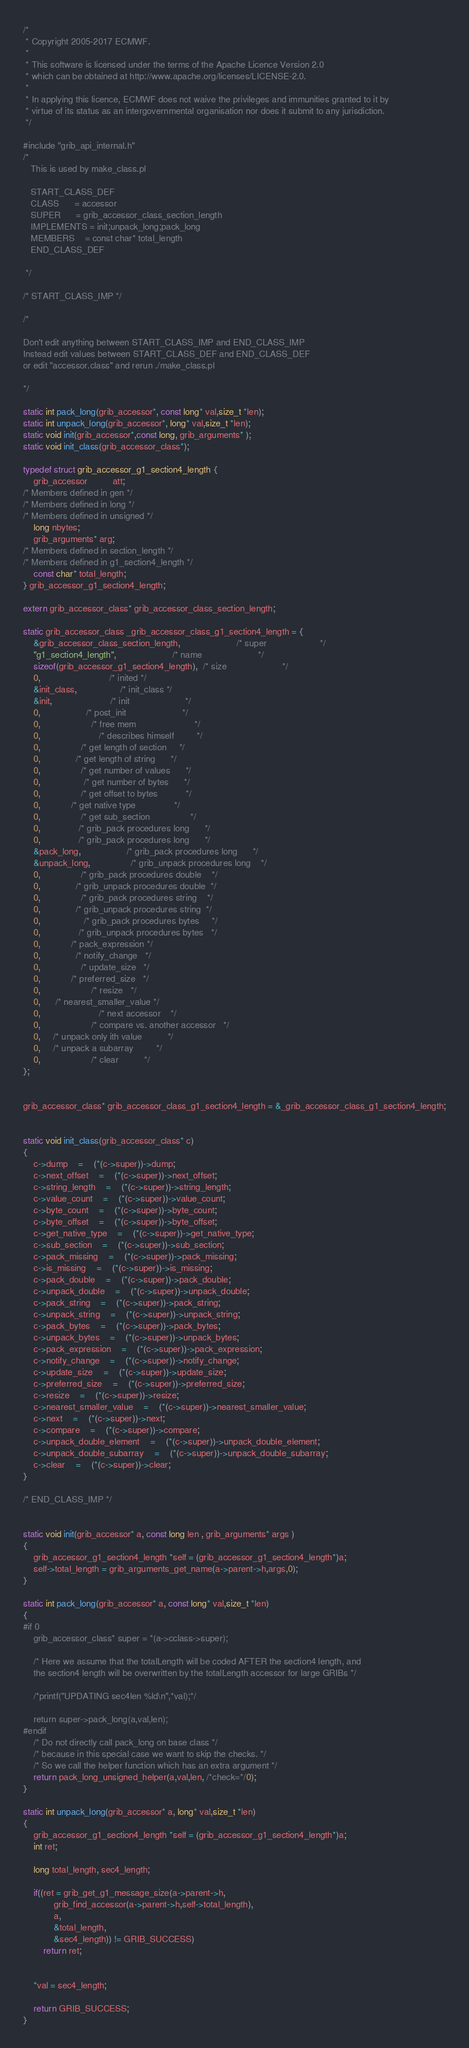Convert code to text. <code><loc_0><loc_0><loc_500><loc_500><_C_>/*
 * Copyright 2005-2017 ECMWF.
 *
 * This software is licensed under the terms of the Apache Licence Version 2.0
 * which can be obtained at http://www.apache.org/licenses/LICENSE-2.0.
 *
 * In applying this licence, ECMWF does not waive the privileges and immunities granted to it by
 * virtue of its status as an intergovernmental organisation nor does it submit to any jurisdiction.
 */

#include "grib_api_internal.h"
/* 
   This is used by make_class.pl

   START_CLASS_DEF
   CLASS      = accessor
   SUPER      = grib_accessor_class_section_length
   IMPLEMENTS = init;unpack_long;pack_long
   MEMBERS    = const char* total_length
   END_CLASS_DEF

 */

/* START_CLASS_IMP */

/*

Don't edit anything between START_CLASS_IMP and END_CLASS_IMP
Instead edit values between START_CLASS_DEF and END_CLASS_DEF
or edit "accessor.class" and rerun ./make_class.pl

*/

static int pack_long(grib_accessor*, const long* val,size_t *len);
static int unpack_long(grib_accessor*, long* val,size_t *len);
static void init(grib_accessor*,const long, grib_arguments* );
static void init_class(grib_accessor_class*);

typedef struct grib_accessor_g1_section4_length {
    grib_accessor          att;
/* Members defined in gen */
/* Members defined in long */
/* Members defined in unsigned */
	long nbytes;
	grib_arguments* arg;
/* Members defined in section_length */
/* Members defined in g1_section4_length */
	const char* total_length;
} grib_accessor_g1_section4_length;

extern grib_accessor_class* grib_accessor_class_section_length;

static grib_accessor_class _grib_accessor_class_g1_section4_length = {
    &grib_accessor_class_section_length,                      /* super                     */
    "g1_section4_length",                      /* name                      */
    sizeof(grib_accessor_g1_section4_length),  /* size                      */
    0,                           /* inited */
    &init_class,                 /* init_class */
    &init,                       /* init                      */
    0,                  /* post_init                      */
    0,                    /* free mem                       */
    0,                       /* describes himself         */
    0,                /* get length of section     */
    0,              /* get length of string      */
    0,                /* get number of values      */
    0,                 /* get number of bytes      */
    0,                /* get offset to bytes           */
    0,            /* get native type               */
    0,                /* get sub_section                */
    0,               /* grib_pack procedures long      */
    0,               /* grib_pack procedures long      */
    &pack_long,                  /* grib_pack procedures long      */
    &unpack_long,                /* grib_unpack procedures long    */
    0,                /* grib_pack procedures double    */
    0,              /* grib_unpack procedures double  */
    0,                /* grib_pack procedures string    */
    0,              /* grib_unpack procedures string  */
    0,                 /* grib_pack procedures bytes     */
    0,               /* grib_unpack procedures bytes   */
    0,            /* pack_expression */
    0,              /* notify_change   */
    0,                /* update_size   */
    0,            /* preferred_size   */
    0,                    /* resize   */
    0,      /* nearest_smaller_value */
    0,                       /* next accessor    */
    0,                    /* compare vs. another accessor   */
    0,     /* unpack only ith value          */
    0,     /* unpack a subarray         */
    0,             		/* clear          */
};


grib_accessor_class* grib_accessor_class_g1_section4_length = &_grib_accessor_class_g1_section4_length;


static void init_class(grib_accessor_class* c)
{
	c->dump	=	(*(c->super))->dump;
	c->next_offset	=	(*(c->super))->next_offset;
	c->string_length	=	(*(c->super))->string_length;
	c->value_count	=	(*(c->super))->value_count;
	c->byte_count	=	(*(c->super))->byte_count;
	c->byte_offset	=	(*(c->super))->byte_offset;
	c->get_native_type	=	(*(c->super))->get_native_type;
	c->sub_section	=	(*(c->super))->sub_section;
	c->pack_missing	=	(*(c->super))->pack_missing;
	c->is_missing	=	(*(c->super))->is_missing;
	c->pack_double	=	(*(c->super))->pack_double;
	c->unpack_double	=	(*(c->super))->unpack_double;
	c->pack_string	=	(*(c->super))->pack_string;
	c->unpack_string	=	(*(c->super))->unpack_string;
	c->pack_bytes	=	(*(c->super))->pack_bytes;
	c->unpack_bytes	=	(*(c->super))->unpack_bytes;
	c->pack_expression	=	(*(c->super))->pack_expression;
	c->notify_change	=	(*(c->super))->notify_change;
	c->update_size	=	(*(c->super))->update_size;
	c->preferred_size	=	(*(c->super))->preferred_size;
	c->resize	=	(*(c->super))->resize;
	c->nearest_smaller_value	=	(*(c->super))->nearest_smaller_value;
	c->next	=	(*(c->super))->next;
	c->compare	=	(*(c->super))->compare;
	c->unpack_double_element	=	(*(c->super))->unpack_double_element;
	c->unpack_double_subarray	=	(*(c->super))->unpack_double_subarray;
	c->clear	=	(*(c->super))->clear;
}

/* END_CLASS_IMP */


static void init(grib_accessor* a, const long len , grib_arguments* args )
{
    grib_accessor_g1_section4_length *self = (grib_accessor_g1_section4_length*)a;
	self->total_length = grib_arguments_get_name(a->parent->h,args,0);
}

static int pack_long(grib_accessor* a, const long* val,size_t *len)
{
#if 0
	grib_accessor_class* super = *(a->cclass->super);  

	/* Here we assume that the totalLength will be coded AFTER the section4 length, and 
	the section4 length will be overwritten by the totalLength accessor for large GRIBs */
	
	/*printf("UPDATING sec4len %ld\n",*val);*/

	return super->pack_long(a,val,len);
#endif
	/* Do not directly call pack_long on base class */
	/* because in this special case we want to skip the checks. */
	/* So we call the helper function which has an extra argument */
	return pack_long_unsigned_helper(a,val,len, /*check=*/0);
}

static int unpack_long(grib_accessor* a, long* val,size_t *len)
{
	grib_accessor_g1_section4_length *self = (grib_accessor_g1_section4_length*)a;
	int ret;

	long total_length, sec4_length;

	if((ret = grib_get_g1_message_size(a->parent->h,
			grib_find_accessor(a->parent->h,self->total_length),
			a,
			&total_length,
			&sec4_length)) != GRIB_SUCCESS)
		return ret;


	*val = sec4_length;

	return GRIB_SUCCESS;
}
</code> 